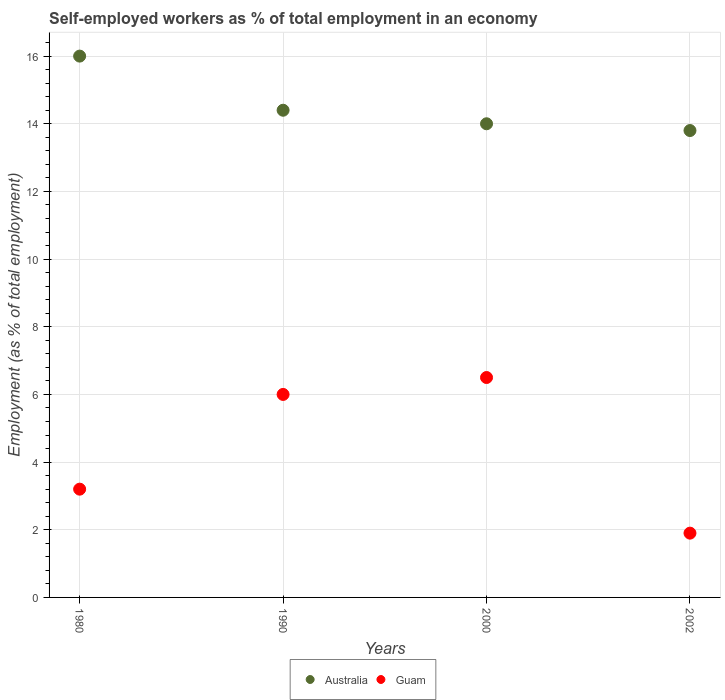How many different coloured dotlines are there?
Give a very brief answer. 2. What is the percentage of self-employed workers in Guam in 2002?
Your answer should be very brief. 1.9. Across all years, what is the maximum percentage of self-employed workers in Australia?
Make the answer very short. 16. Across all years, what is the minimum percentage of self-employed workers in Guam?
Provide a succinct answer. 1.9. In which year was the percentage of self-employed workers in Australia maximum?
Make the answer very short. 1980. What is the total percentage of self-employed workers in Australia in the graph?
Offer a very short reply. 58.2. What is the difference between the percentage of self-employed workers in Australia in 1980 and that in 2000?
Offer a very short reply. 2. What is the difference between the percentage of self-employed workers in Guam in 1980 and the percentage of self-employed workers in Australia in 1990?
Provide a short and direct response. -11.2. What is the average percentage of self-employed workers in Australia per year?
Ensure brevity in your answer.  14.55. In the year 1990, what is the difference between the percentage of self-employed workers in Australia and percentage of self-employed workers in Guam?
Ensure brevity in your answer.  8.4. What is the ratio of the percentage of self-employed workers in Guam in 1980 to that in 2000?
Provide a succinct answer. 0.49. Is the percentage of self-employed workers in Australia in 1990 less than that in 2000?
Keep it short and to the point. No. What is the difference between the highest and the second highest percentage of self-employed workers in Guam?
Your answer should be very brief. 0.5. What is the difference between the highest and the lowest percentage of self-employed workers in Guam?
Provide a short and direct response. 4.6. In how many years, is the percentage of self-employed workers in Australia greater than the average percentage of self-employed workers in Australia taken over all years?
Your answer should be very brief. 1. Is the sum of the percentage of self-employed workers in Australia in 1990 and 2000 greater than the maximum percentage of self-employed workers in Guam across all years?
Make the answer very short. Yes. Does the percentage of self-employed workers in Guam monotonically increase over the years?
Keep it short and to the point. No. How many years are there in the graph?
Ensure brevity in your answer.  4. What is the difference between two consecutive major ticks on the Y-axis?
Provide a short and direct response. 2. Does the graph contain grids?
Give a very brief answer. Yes. Where does the legend appear in the graph?
Offer a terse response. Bottom center. How many legend labels are there?
Your answer should be compact. 2. How are the legend labels stacked?
Offer a terse response. Horizontal. What is the title of the graph?
Your answer should be very brief. Self-employed workers as % of total employment in an economy. What is the label or title of the X-axis?
Make the answer very short. Years. What is the label or title of the Y-axis?
Provide a succinct answer. Employment (as % of total employment). What is the Employment (as % of total employment) of Guam in 1980?
Your answer should be very brief. 3.2. What is the Employment (as % of total employment) in Australia in 1990?
Offer a terse response. 14.4. What is the Employment (as % of total employment) of Australia in 2000?
Ensure brevity in your answer.  14. What is the Employment (as % of total employment) of Australia in 2002?
Ensure brevity in your answer.  13.8. What is the Employment (as % of total employment) of Guam in 2002?
Provide a short and direct response. 1.9. Across all years, what is the maximum Employment (as % of total employment) of Australia?
Your answer should be very brief. 16. Across all years, what is the maximum Employment (as % of total employment) of Guam?
Your answer should be compact. 6.5. Across all years, what is the minimum Employment (as % of total employment) of Australia?
Offer a terse response. 13.8. Across all years, what is the minimum Employment (as % of total employment) of Guam?
Provide a succinct answer. 1.9. What is the total Employment (as % of total employment) in Australia in the graph?
Your response must be concise. 58.2. What is the difference between the Employment (as % of total employment) of Guam in 1980 and that in 1990?
Your answer should be very brief. -2.8. What is the difference between the Employment (as % of total employment) in Guam in 1980 and that in 2000?
Offer a very short reply. -3.3. What is the difference between the Employment (as % of total employment) of Australia in 1990 and that in 2000?
Your response must be concise. 0.4. What is the difference between the Employment (as % of total employment) of Guam in 2000 and that in 2002?
Offer a very short reply. 4.6. What is the difference between the Employment (as % of total employment) in Australia in 1990 and the Employment (as % of total employment) in Guam in 2000?
Provide a short and direct response. 7.9. What is the average Employment (as % of total employment) in Australia per year?
Your answer should be compact. 14.55. What is the average Employment (as % of total employment) in Guam per year?
Provide a succinct answer. 4.4. In the year 1980, what is the difference between the Employment (as % of total employment) in Australia and Employment (as % of total employment) in Guam?
Provide a succinct answer. 12.8. In the year 1990, what is the difference between the Employment (as % of total employment) in Australia and Employment (as % of total employment) in Guam?
Your answer should be compact. 8.4. In the year 2002, what is the difference between the Employment (as % of total employment) of Australia and Employment (as % of total employment) of Guam?
Make the answer very short. 11.9. What is the ratio of the Employment (as % of total employment) of Guam in 1980 to that in 1990?
Provide a succinct answer. 0.53. What is the ratio of the Employment (as % of total employment) in Guam in 1980 to that in 2000?
Your answer should be compact. 0.49. What is the ratio of the Employment (as % of total employment) of Australia in 1980 to that in 2002?
Offer a very short reply. 1.16. What is the ratio of the Employment (as % of total employment) of Guam in 1980 to that in 2002?
Offer a terse response. 1.68. What is the ratio of the Employment (as % of total employment) of Australia in 1990 to that in 2000?
Your response must be concise. 1.03. What is the ratio of the Employment (as % of total employment) in Guam in 1990 to that in 2000?
Provide a short and direct response. 0.92. What is the ratio of the Employment (as % of total employment) in Australia in 1990 to that in 2002?
Offer a very short reply. 1.04. What is the ratio of the Employment (as % of total employment) in Guam in 1990 to that in 2002?
Give a very brief answer. 3.16. What is the ratio of the Employment (as % of total employment) in Australia in 2000 to that in 2002?
Your answer should be very brief. 1.01. What is the ratio of the Employment (as % of total employment) of Guam in 2000 to that in 2002?
Provide a short and direct response. 3.42. What is the difference between the highest and the second highest Employment (as % of total employment) in Australia?
Make the answer very short. 1.6. 